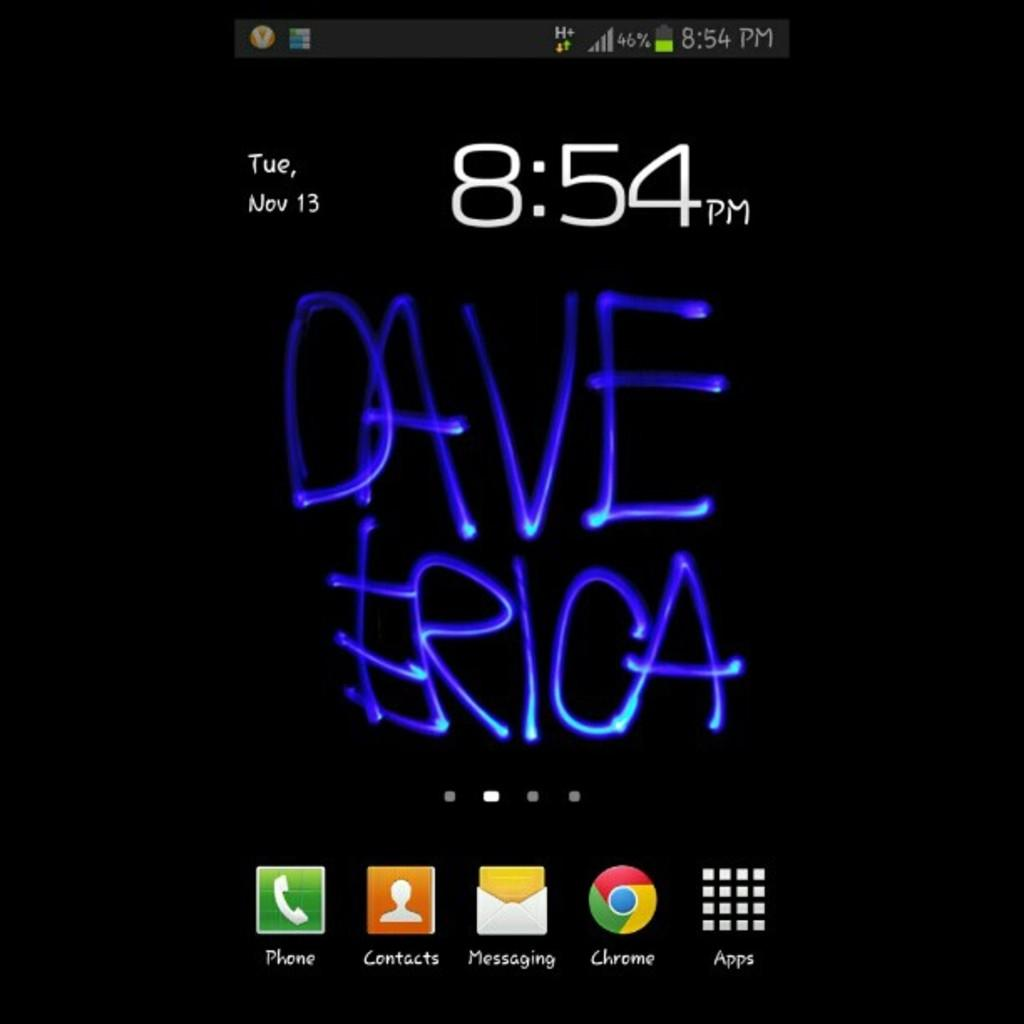Provide a one-sentence caption for the provided image. Dave and Erica's names are written below the time, which is 8:54 pm. 